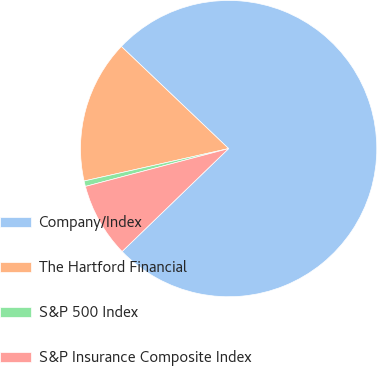Convert chart to OTSL. <chart><loc_0><loc_0><loc_500><loc_500><pie_chart><fcel>Company/Index<fcel>The Hartford Financial<fcel>S&P 500 Index<fcel>S&P Insurance Composite Index<nl><fcel>75.67%<fcel>15.62%<fcel>0.6%<fcel>8.11%<nl></chart> 